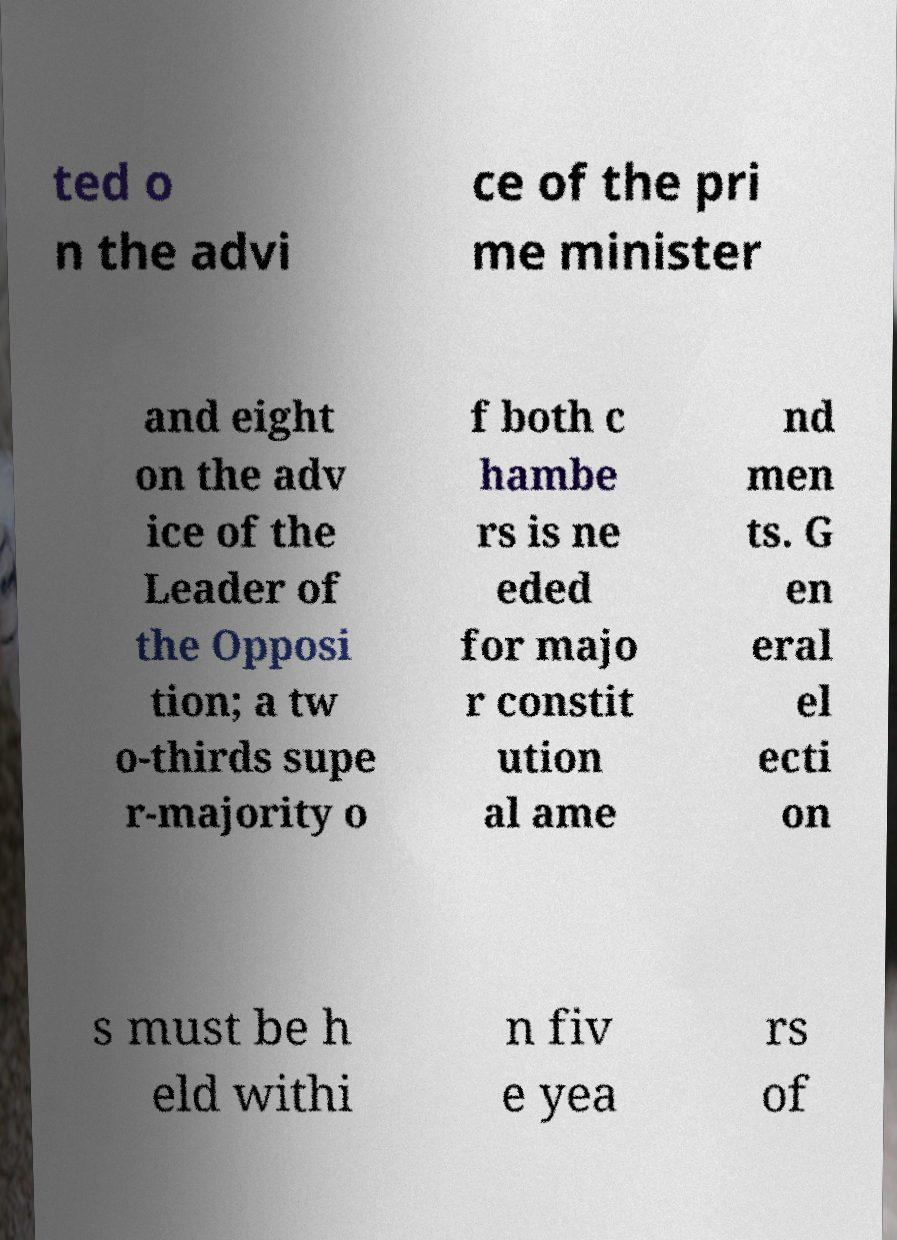Could you provide some educational insights based on the fragmented text from this image? Certainly! The fragmented text refers to a 'super-majority,' which is a larger than simple majority, often required for significant legal changes. This can promote stability and ensure any major amendments have broad support. Regular elections mentioned reflect principles of democratic systems, where periodic voting is an essential mechanism for ensuring government accountability to the populace. 